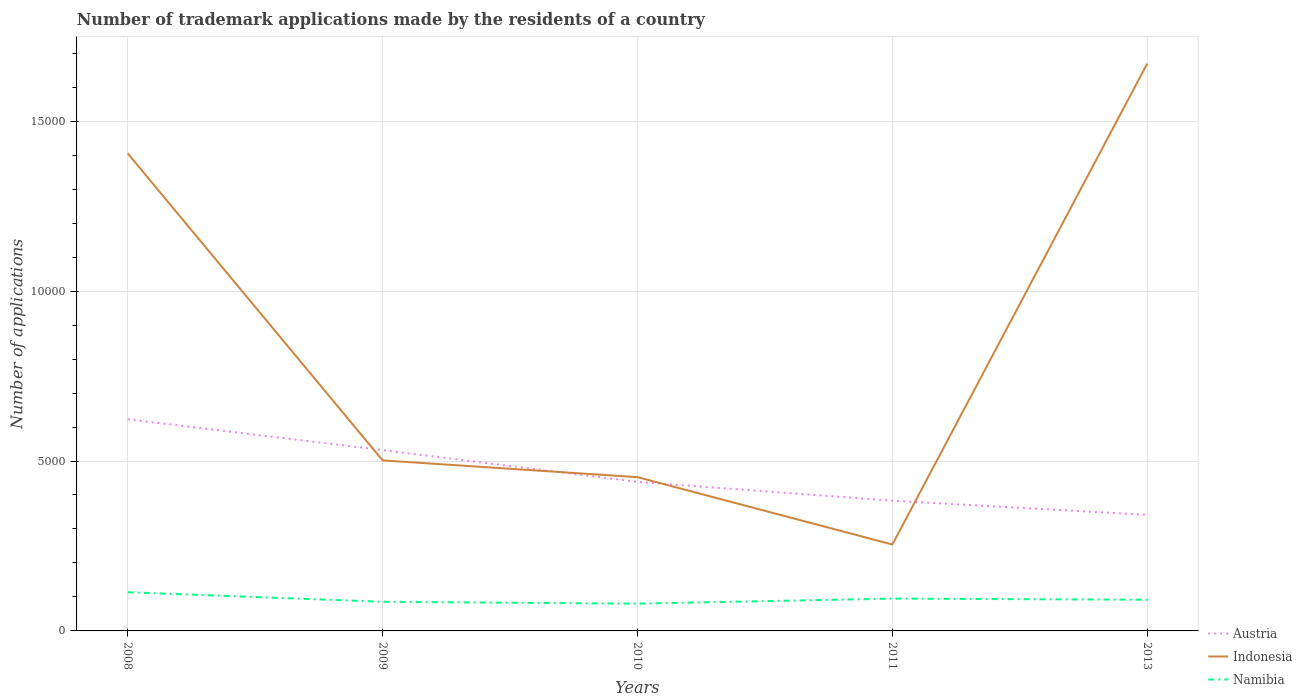How many different coloured lines are there?
Ensure brevity in your answer.  3. Does the line corresponding to Austria intersect with the line corresponding to Indonesia?
Offer a very short reply. Yes. Is the number of lines equal to the number of legend labels?
Make the answer very short. Yes. Across all years, what is the maximum number of trademark applications made by the residents in Namibia?
Your answer should be very brief. 802. What is the total number of trademark applications made by the residents in Austria in the graph?
Keep it short and to the point. 2813. What is the difference between the highest and the second highest number of trademark applications made by the residents in Austria?
Your answer should be very brief. 2813. Is the number of trademark applications made by the residents in Indonesia strictly greater than the number of trademark applications made by the residents in Namibia over the years?
Offer a very short reply. No. How many lines are there?
Keep it short and to the point. 3. How many years are there in the graph?
Offer a very short reply. 5. Does the graph contain grids?
Make the answer very short. Yes. How many legend labels are there?
Keep it short and to the point. 3. What is the title of the graph?
Provide a short and direct response. Number of trademark applications made by the residents of a country. What is the label or title of the Y-axis?
Your response must be concise. Number of applications. What is the Number of applications in Austria in 2008?
Give a very brief answer. 6228. What is the Number of applications in Indonesia in 2008?
Keep it short and to the point. 1.41e+04. What is the Number of applications in Namibia in 2008?
Offer a terse response. 1139. What is the Number of applications of Austria in 2009?
Your answer should be very brief. 5321. What is the Number of applications of Indonesia in 2009?
Provide a short and direct response. 5018. What is the Number of applications of Namibia in 2009?
Ensure brevity in your answer.  858. What is the Number of applications of Austria in 2010?
Offer a terse response. 4386. What is the Number of applications in Indonesia in 2010?
Give a very brief answer. 4525. What is the Number of applications in Namibia in 2010?
Your answer should be very brief. 802. What is the Number of applications of Austria in 2011?
Provide a succinct answer. 3831. What is the Number of applications in Indonesia in 2011?
Offer a very short reply. 2543. What is the Number of applications of Namibia in 2011?
Your answer should be compact. 951. What is the Number of applications of Austria in 2013?
Your answer should be compact. 3415. What is the Number of applications in Indonesia in 2013?
Provide a succinct answer. 1.67e+04. What is the Number of applications of Namibia in 2013?
Your answer should be very brief. 918. Across all years, what is the maximum Number of applications of Austria?
Offer a terse response. 6228. Across all years, what is the maximum Number of applications of Indonesia?
Provide a short and direct response. 1.67e+04. Across all years, what is the maximum Number of applications of Namibia?
Your response must be concise. 1139. Across all years, what is the minimum Number of applications in Austria?
Offer a terse response. 3415. Across all years, what is the minimum Number of applications of Indonesia?
Ensure brevity in your answer.  2543. Across all years, what is the minimum Number of applications in Namibia?
Your answer should be very brief. 802. What is the total Number of applications in Austria in the graph?
Provide a short and direct response. 2.32e+04. What is the total Number of applications of Indonesia in the graph?
Offer a very short reply. 4.28e+04. What is the total Number of applications of Namibia in the graph?
Your answer should be compact. 4668. What is the difference between the Number of applications in Austria in 2008 and that in 2009?
Make the answer very short. 907. What is the difference between the Number of applications of Indonesia in 2008 and that in 2009?
Ensure brevity in your answer.  9033. What is the difference between the Number of applications in Namibia in 2008 and that in 2009?
Give a very brief answer. 281. What is the difference between the Number of applications of Austria in 2008 and that in 2010?
Your response must be concise. 1842. What is the difference between the Number of applications of Indonesia in 2008 and that in 2010?
Keep it short and to the point. 9526. What is the difference between the Number of applications in Namibia in 2008 and that in 2010?
Your answer should be compact. 337. What is the difference between the Number of applications in Austria in 2008 and that in 2011?
Offer a very short reply. 2397. What is the difference between the Number of applications in Indonesia in 2008 and that in 2011?
Make the answer very short. 1.15e+04. What is the difference between the Number of applications of Namibia in 2008 and that in 2011?
Give a very brief answer. 188. What is the difference between the Number of applications in Austria in 2008 and that in 2013?
Make the answer very short. 2813. What is the difference between the Number of applications of Indonesia in 2008 and that in 2013?
Ensure brevity in your answer.  -2644. What is the difference between the Number of applications in Namibia in 2008 and that in 2013?
Provide a short and direct response. 221. What is the difference between the Number of applications of Austria in 2009 and that in 2010?
Provide a short and direct response. 935. What is the difference between the Number of applications of Indonesia in 2009 and that in 2010?
Your answer should be compact. 493. What is the difference between the Number of applications of Austria in 2009 and that in 2011?
Provide a succinct answer. 1490. What is the difference between the Number of applications of Indonesia in 2009 and that in 2011?
Offer a very short reply. 2475. What is the difference between the Number of applications in Namibia in 2009 and that in 2011?
Your answer should be compact. -93. What is the difference between the Number of applications in Austria in 2009 and that in 2013?
Make the answer very short. 1906. What is the difference between the Number of applications in Indonesia in 2009 and that in 2013?
Your answer should be very brief. -1.17e+04. What is the difference between the Number of applications of Namibia in 2009 and that in 2013?
Keep it short and to the point. -60. What is the difference between the Number of applications in Austria in 2010 and that in 2011?
Make the answer very short. 555. What is the difference between the Number of applications in Indonesia in 2010 and that in 2011?
Make the answer very short. 1982. What is the difference between the Number of applications in Namibia in 2010 and that in 2011?
Your answer should be compact. -149. What is the difference between the Number of applications of Austria in 2010 and that in 2013?
Keep it short and to the point. 971. What is the difference between the Number of applications of Indonesia in 2010 and that in 2013?
Offer a terse response. -1.22e+04. What is the difference between the Number of applications of Namibia in 2010 and that in 2013?
Make the answer very short. -116. What is the difference between the Number of applications of Austria in 2011 and that in 2013?
Your answer should be compact. 416. What is the difference between the Number of applications in Indonesia in 2011 and that in 2013?
Your answer should be very brief. -1.42e+04. What is the difference between the Number of applications of Austria in 2008 and the Number of applications of Indonesia in 2009?
Your answer should be very brief. 1210. What is the difference between the Number of applications of Austria in 2008 and the Number of applications of Namibia in 2009?
Keep it short and to the point. 5370. What is the difference between the Number of applications of Indonesia in 2008 and the Number of applications of Namibia in 2009?
Give a very brief answer. 1.32e+04. What is the difference between the Number of applications of Austria in 2008 and the Number of applications of Indonesia in 2010?
Provide a succinct answer. 1703. What is the difference between the Number of applications in Austria in 2008 and the Number of applications in Namibia in 2010?
Provide a succinct answer. 5426. What is the difference between the Number of applications of Indonesia in 2008 and the Number of applications of Namibia in 2010?
Offer a very short reply. 1.32e+04. What is the difference between the Number of applications of Austria in 2008 and the Number of applications of Indonesia in 2011?
Provide a short and direct response. 3685. What is the difference between the Number of applications in Austria in 2008 and the Number of applications in Namibia in 2011?
Your answer should be very brief. 5277. What is the difference between the Number of applications in Indonesia in 2008 and the Number of applications in Namibia in 2011?
Your answer should be compact. 1.31e+04. What is the difference between the Number of applications of Austria in 2008 and the Number of applications of Indonesia in 2013?
Your response must be concise. -1.05e+04. What is the difference between the Number of applications of Austria in 2008 and the Number of applications of Namibia in 2013?
Provide a short and direct response. 5310. What is the difference between the Number of applications of Indonesia in 2008 and the Number of applications of Namibia in 2013?
Provide a succinct answer. 1.31e+04. What is the difference between the Number of applications of Austria in 2009 and the Number of applications of Indonesia in 2010?
Ensure brevity in your answer.  796. What is the difference between the Number of applications of Austria in 2009 and the Number of applications of Namibia in 2010?
Offer a terse response. 4519. What is the difference between the Number of applications of Indonesia in 2009 and the Number of applications of Namibia in 2010?
Ensure brevity in your answer.  4216. What is the difference between the Number of applications in Austria in 2009 and the Number of applications in Indonesia in 2011?
Your answer should be very brief. 2778. What is the difference between the Number of applications of Austria in 2009 and the Number of applications of Namibia in 2011?
Keep it short and to the point. 4370. What is the difference between the Number of applications in Indonesia in 2009 and the Number of applications in Namibia in 2011?
Keep it short and to the point. 4067. What is the difference between the Number of applications of Austria in 2009 and the Number of applications of Indonesia in 2013?
Ensure brevity in your answer.  -1.14e+04. What is the difference between the Number of applications of Austria in 2009 and the Number of applications of Namibia in 2013?
Provide a short and direct response. 4403. What is the difference between the Number of applications in Indonesia in 2009 and the Number of applications in Namibia in 2013?
Your answer should be very brief. 4100. What is the difference between the Number of applications of Austria in 2010 and the Number of applications of Indonesia in 2011?
Keep it short and to the point. 1843. What is the difference between the Number of applications in Austria in 2010 and the Number of applications in Namibia in 2011?
Give a very brief answer. 3435. What is the difference between the Number of applications of Indonesia in 2010 and the Number of applications of Namibia in 2011?
Your answer should be very brief. 3574. What is the difference between the Number of applications of Austria in 2010 and the Number of applications of Indonesia in 2013?
Give a very brief answer. -1.23e+04. What is the difference between the Number of applications in Austria in 2010 and the Number of applications in Namibia in 2013?
Your answer should be very brief. 3468. What is the difference between the Number of applications in Indonesia in 2010 and the Number of applications in Namibia in 2013?
Offer a terse response. 3607. What is the difference between the Number of applications of Austria in 2011 and the Number of applications of Indonesia in 2013?
Offer a terse response. -1.29e+04. What is the difference between the Number of applications of Austria in 2011 and the Number of applications of Namibia in 2013?
Offer a very short reply. 2913. What is the difference between the Number of applications in Indonesia in 2011 and the Number of applications in Namibia in 2013?
Your answer should be very brief. 1625. What is the average Number of applications in Austria per year?
Your response must be concise. 4636.2. What is the average Number of applications in Indonesia per year?
Keep it short and to the point. 8566.4. What is the average Number of applications of Namibia per year?
Make the answer very short. 933.6. In the year 2008, what is the difference between the Number of applications in Austria and Number of applications in Indonesia?
Offer a very short reply. -7823. In the year 2008, what is the difference between the Number of applications in Austria and Number of applications in Namibia?
Provide a short and direct response. 5089. In the year 2008, what is the difference between the Number of applications of Indonesia and Number of applications of Namibia?
Ensure brevity in your answer.  1.29e+04. In the year 2009, what is the difference between the Number of applications of Austria and Number of applications of Indonesia?
Ensure brevity in your answer.  303. In the year 2009, what is the difference between the Number of applications in Austria and Number of applications in Namibia?
Provide a short and direct response. 4463. In the year 2009, what is the difference between the Number of applications in Indonesia and Number of applications in Namibia?
Provide a short and direct response. 4160. In the year 2010, what is the difference between the Number of applications in Austria and Number of applications in Indonesia?
Your answer should be very brief. -139. In the year 2010, what is the difference between the Number of applications in Austria and Number of applications in Namibia?
Provide a succinct answer. 3584. In the year 2010, what is the difference between the Number of applications of Indonesia and Number of applications of Namibia?
Offer a very short reply. 3723. In the year 2011, what is the difference between the Number of applications in Austria and Number of applications in Indonesia?
Offer a terse response. 1288. In the year 2011, what is the difference between the Number of applications of Austria and Number of applications of Namibia?
Your response must be concise. 2880. In the year 2011, what is the difference between the Number of applications in Indonesia and Number of applications in Namibia?
Your response must be concise. 1592. In the year 2013, what is the difference between the Number of applications of Austria and Number of applications of Indonesia?
Ensure brevity in your answer.  -1.33e+04. In the year 2013, what is the difference between the Number of applications in Austria and Number of applications in Namibia?
Keep it short and to the point. 2497. In the year 2013, what is the difference between the Number of applications of Indonesia and Number of applications of Namibia?
Give a very brief answer. 1.58e+04. What is the ratio of the Number of applications in Austria in 2008 to that in 2009?
Your answer should be very brief. 1.17. What is the ratio of the Number of applications in Indonesia in 2008 to that in 2009?
Provide a succinct answer. 2.8. What is the ratio of the Number of applications in Namibia in 2008 to that in 2009?
Provide a short and direct response. 1.33. What is the ratio of the Number of applications in Austria in 2008 to that in 2010?
Provide a succinct answer. 1.42. What is the ratio of the Number of applications in Indonesia in 2008 to that in 2010?
Make the answer very short. 3.11. What is the ratio of the Number of applications in Namibia in 2008 to that in 2010?
Keep it short and to the point. 1.42. What is the ratio of the Number of applications of Austria in 2008 to that in 2011?
Your response must be concise. 1.63. What is the ratio of the Number of applications of Indonesia in 2008 to that in 2011?
Offer a terse response. 5.53. What is the ratio of the Number of applications of Namibia in 2008 to that in 2011?
Provide a succinct answer. 1.2. What is the ratio of the Number of applications in Austria in 2008 to that in 2013?
Your answer should be compact. 1.82. What is the ratio of the Number of applications of Indonesia in 2008 to that in 2013?
Provide a short and direct response. 0.84. What is the ratio of the Number of applications of Namibia in 2008 to that in 2013?
Your response must be concise. 1.24. What is the ratio of the Number of applications in Austria in 2009 to that in 2010?
Your answer should be very brief. 1.21. What is the ratio of the Number of applications of Indonesia in 2009 to that in 2010?
Offer a very short reply. 1.11. What is the ratio of the Number of applications in Namibia in 2009 to that in 2010?
Give a very brief answer. 1.07. What is the ratio of the Number of applications of Austria in 2009 to that in 2011?
Provide a succinct answer. 1.39. What is the ratio of the Number of applications of Indonesia in 2009 to that in 2011?
Provide a short and direct response. 1.97. What is the ratio of the Number of applications in Namibia in 2009 to that in 2011?
Provide a succinct answer. 0.9. What is the ratio of the Number of applications in Austria in 2009 to that in 2013?
Offer a very short reply. 1.56. What is the ratio of the Number of applications of Indonesia in 2009 to that in 2013?
Keep it short and to the point. 0.3. What is the ratio of the Number of applications of Namibia in 2009 to that in 2013?
Make the answer very short. 0.93. What is the ratio of the Number of applications of Austria in 2010 to that in 2011?
Keep it short and to the point. 1.14. What is the ratio of the Number of applications of Indonesia in 2010 to that in 2011?
Your answer should be very brief. 1.78. What is the ratio of the Number of applications in Namibia in 2010 to that in 2011?
Make the answer very short. 0.84. What is the ratio of the Number of applications in Austria in 2010 to that in 2013?
Make the answer very short. 1.28. What is the ratio of the Number of applications in Indonesia in 2010 to that in 2013?
Provide a succinct answer. 0.27. What is the ratio of the Number of applications in Namibia in 2010 to that in 2013?
Ensure brevity in your answer.  0.87. What is the ratio of the Number of applications of Austria in 2011 to that in 2013?
Keep it short and to the point. 1.12. What is the ratio of the Number of applications of Indonesia in 2011 to that in 2013?
Offer a terse response. 0.15. What is the ratio of the Number of applications of Namibia in 2011 to that in 2013?
Provide a short and direct response. 1.04. What is the difference between the highest and the second highest Number of applications of Austria?
Give a very brief answer. 907. What is the difference between the highest and the second highest Number of applications of Indonesia?
Ensure brevity in your answer.  2644. What is the difference between the highest and the second highest Number of applications of Namibia?
Offer a terse response. 188. What is the difference between the highest and the lowest Number of applications of Austria?
Offer a very short reply. 2813. What is the difference between the highest and the lowest Number of applications in Indonesia?
Keep it short and to the point. 1.42e+04. What is the difference between the highest and the lowest Number of applications of Namibia?
Provide a succinct answer. 337. 